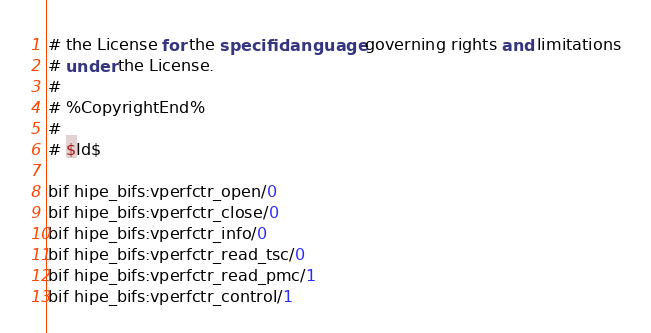Convert code to text. <code><loc_0><loc_0><loc_500><loc_500><_SQL_># the License for the specific language governing rights and limitations
# under the License.
# 
# %CopyrightEnd%
#
# $Id$

bif hipe_bifs:vperfctr_open/0
bif hipe_bifs:vperfctr_close/0
bif hipe_bifs:vperfctr_info/0
bif hipe_bifs:vperfctr_read_tsc/0
bif hipe_bifs:vperfctr_read_pmc/1
bif hipe_bifs:vperfctr_control/1
</code> 